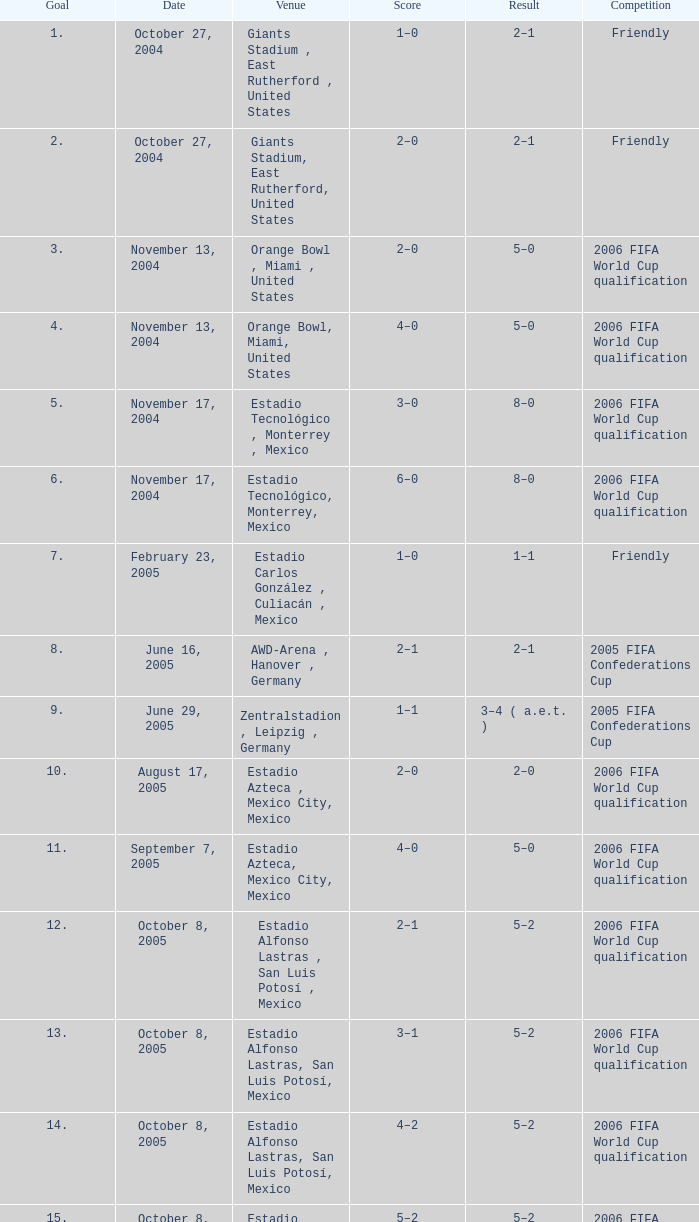Which Score has a Date of october 8, 2005, and a Venue of estadio alfonso lastras, san luis potosí, mexico? 2–1, 3–1, 4–2, 5–2. 